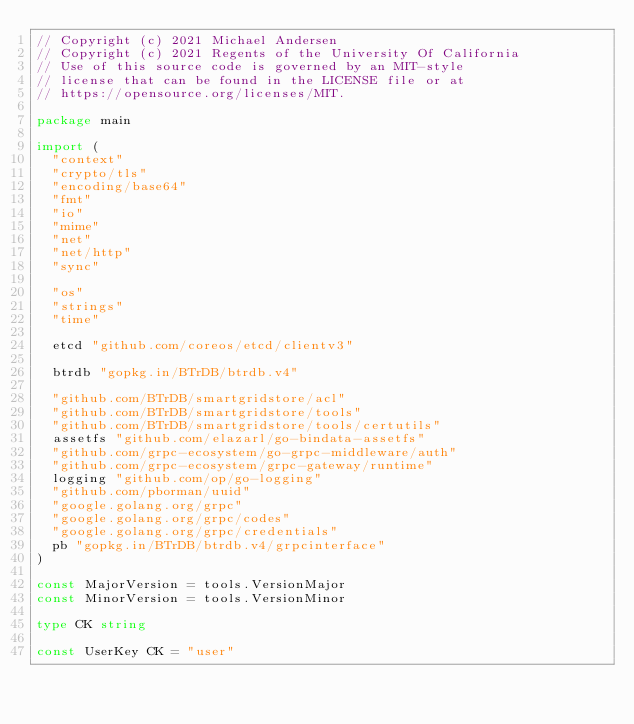Convert code to text. <code><loc_0><loc_0><loc_500><loc_500><_Go_>// Copyright (c) 2021 Michael Andersen
// Copyright (c) 2021 Regents of the University Of California
// Use of this source code is governed by an MIT-style
// license that can be found in the LICENSE file or at
// https://opensource.org/licenses/MIT.

package main

import (
	"context"
	"crypto/tls"
	"encoding/base64"
	"fmt"
	"io"
	"mime"
	"net"
	"net/http"
	"sync"

	"os"
	"strings"
	"time"

	etcd "github.com/coreos/etcd/clientv3"

	btrdb "gopkg.in/BTrDB/btrdb.v4"

	"github.com/BTrDB/smartgridstore/acl"
	"github.com/BTrDB/smartgridstore/tools"
	"github.com/BTrDB/smartgridstore/tools/certutils"
	assetfs "github.com/elazarl/go-bindata-assetfs"
	"github.com/grpc-ecosystem/go-grpc-middleware/auth"
	"github.com/grpc-ecosystem/grpc-gateway/runtime"
	logging "github.com/op/go-logging"
	"github.com/pborman/uuid"
	"google.golang.org/grpc"
	"google.golang.org/grpc/codes"
	"google.golang.org/grpc/credentials"
	pb "gopkg.in/BTrDB/btrdb.v4/grpcinterface"
)

const MajorVersion = tools.VersionMajor
const MinorVersion = tools.VersionMinor

type CK string

const UserKey CK = "user"
</code> 